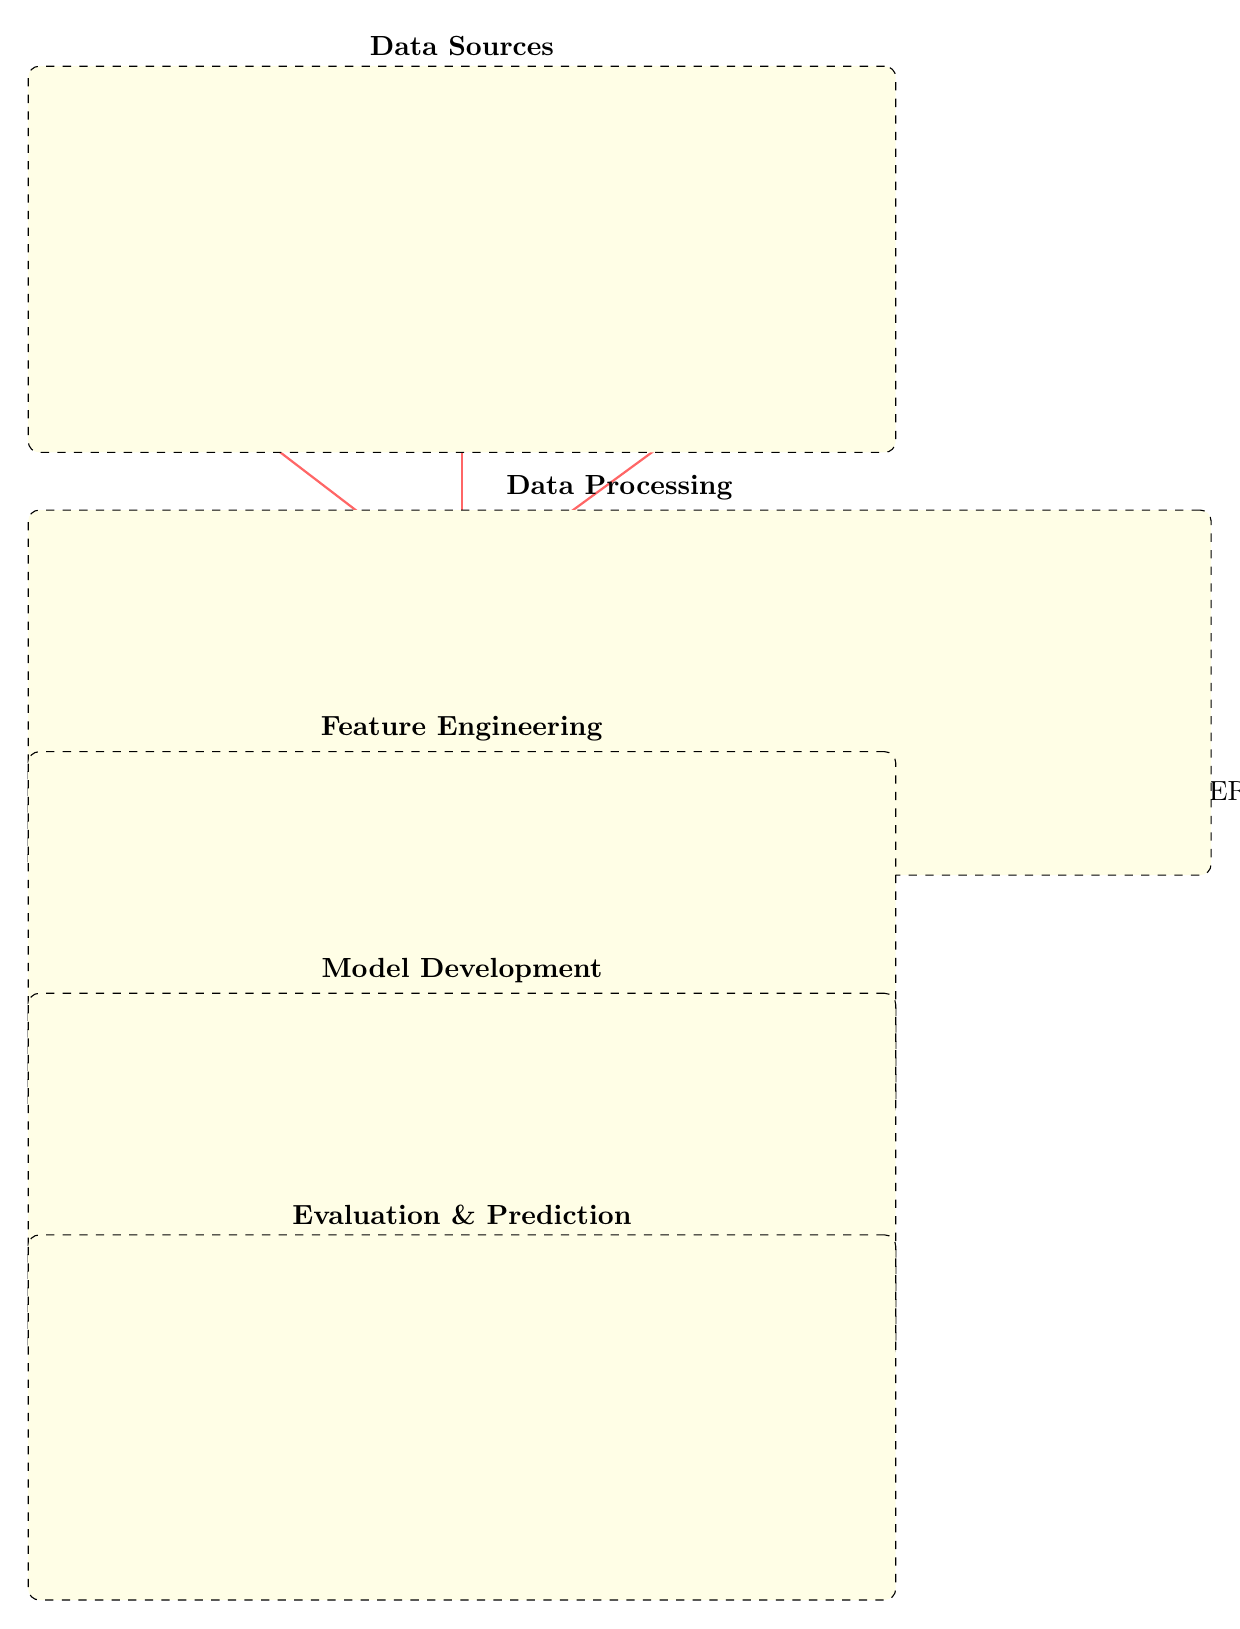What are the three data sources in the diagram? The diagram shows three data sources: Stock Prices, News Headlines, and Social Media Posts. These nodes are positioned below the Data Collection node, indicating they are inputs for this process.
Answer: Stock Prices, News Headlines, Social Media Posts What type of analysis is conducted after the data is cleaned? After the data cleaning step, the next step is Sentiment Analysis, as shown in the Data Processing section of the diagram. The Cleaning block leads to the Sentiment Analysis block, indicating the flow of processing.
Answer: Sentiment Analysis How many blocks are in the Model Development section? The Model Development section consists of three blocks: Model Training, Train/Test Split, and ML Models. Counting these blocks gives a total of three in that section of the diagram.
Answer: 3 What flows from Feature Extraction to Model Training? In the diagram, the flow from Feature Extraction to Model Training includes Stock Price Features and Sentiment Scores. These outputs are needed for the training of ML models in the subsequent step.
Answer: Stock Price Features, Sentiment Scores Which tools are mentioned under Sentiment Analysis? The diagram mentions TextBlob and VADER as tools under the Sentiment Analysis block. This indicates the specific methods used to perform sentiment analysis in this process.
Answer: TextBlob, VADER What is the final output of the diagram? The final output of the diagram is Stock Price Prediction, as indicated in the Evaluation & Prediction section, where the connection from Model Evaluation leads to this prediction outcome.
Answer: Stock Price Prediction How does Data Collection connect to Data Preprocessing? Data Collection connects to Data Preprocessing through the lines that lead from Stock Prices, News Headlines, and Social Media Posts directly to the Data Preprocessing block. This shows how collected data is subsequently processed.
Answer: Through direct connections What is the purpose of the Metrics block in the diagram? The Metrics block serves as an evaluation step, where the model's performance is quantified and assessed after the Model Training stage. It directly connects to Model Evaluation, demonstrating its role in the process.
Answer: Evaluation of model performance 